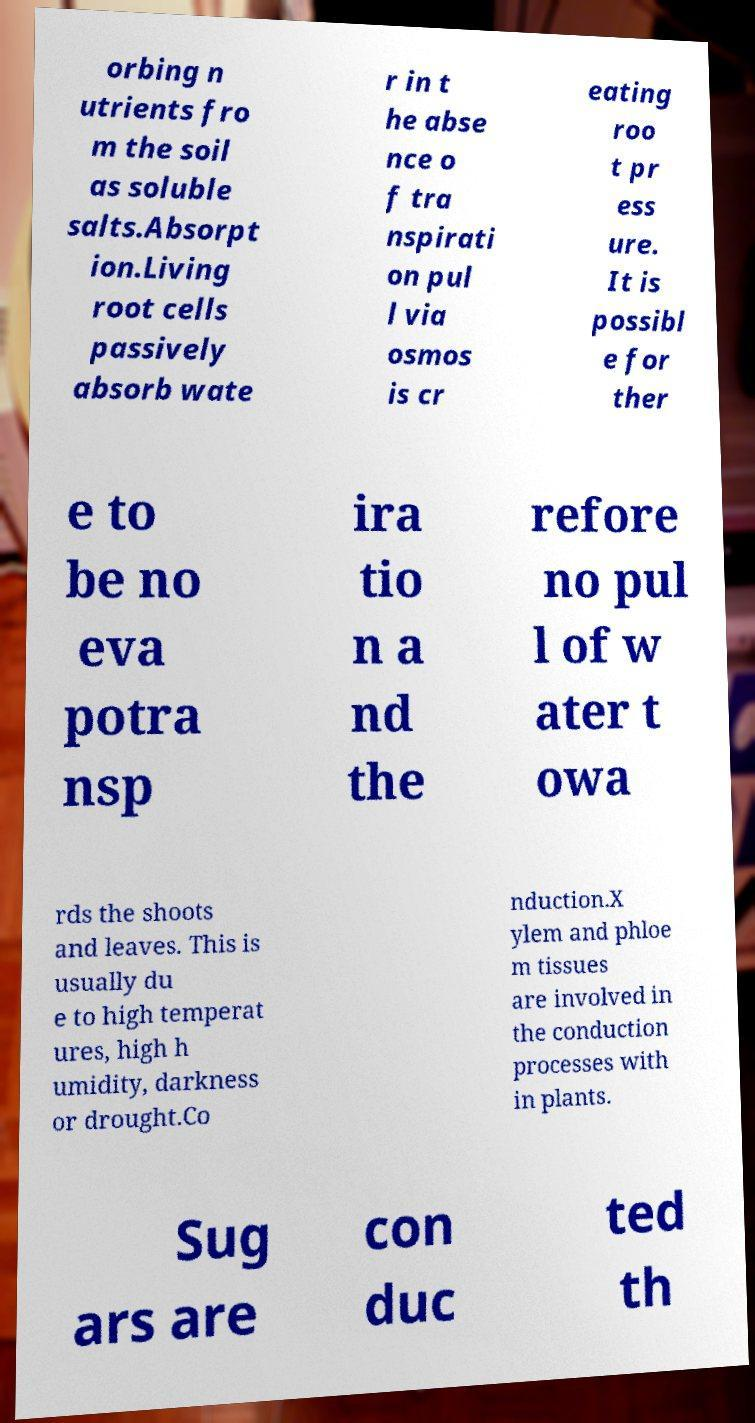Please identify and transcribe the text found in this image. orbing n utrients fro m the soil as soluble salts.Absorpt ion.Living root cells passively absorb wate r in t he abse nce o f tra nspirati on pul l via osmos is cr eating roo t pr ess ure. It is possibl e for ther e to be no eva potra nsp ira tio n a nd the refore no pul l of w ater t owa rds the shoots and leaves. This is usually du e to high temperat ures, high h umidity, darkness or drought.Co nduction.X ylem and phloe m tissues are involved in the conduction processes with in plants. Sug ars are con duc ted th 